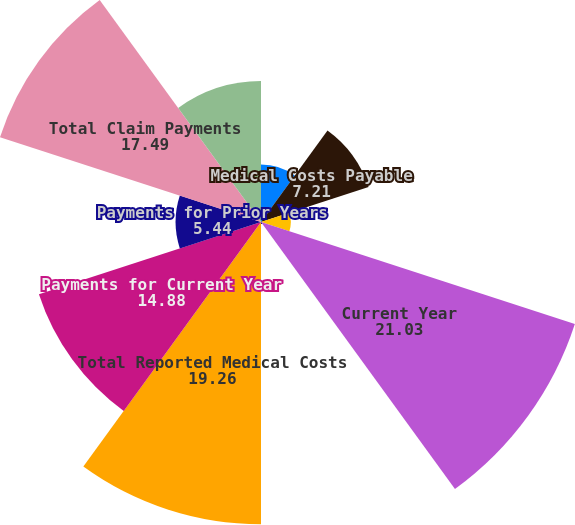<chart> <loc_0><loc_0><loc_500><loc_500><pie_chart><fcel>(in millions)<fcel>Medical Costs Payable<fcel>Acquisitions<fcel>Current Year<fcel>Prior Years<fcel>Total Reported Medical Costs<fcel>Payments for Current Year<fcel>Payments for Prior Years<fcel>Total Claim Payments<fcel>Medical Costs Payable End of<nl><fcel>3.67%<fcel>7.21%<fcel>1.9%<fcel>21.03%<fcel>0.13%<fcel>19.26%<fcel>14.88%<fcel>5.44%<fcel>17.49%<fcel>8.98%<nl></chart> 